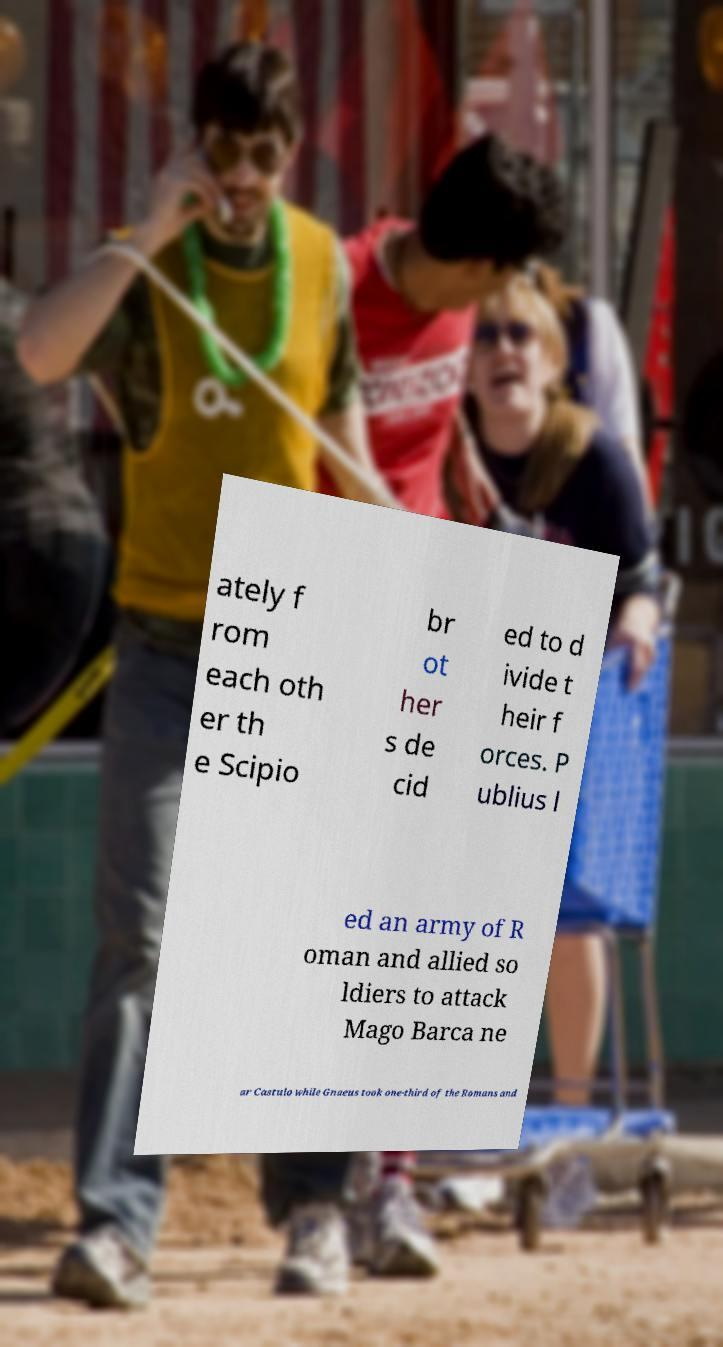What messages or text are displayed in this image? I need them in a readable, typed format. ately f rom each oth er th e Scipio br ot her s de cid ed to d ivide t heir f orces. P ublius l ed an army of R oman and allied so ldiers to attack Mago Barca ne ar Castulo while Gnaeus took one-third of the Romans and 